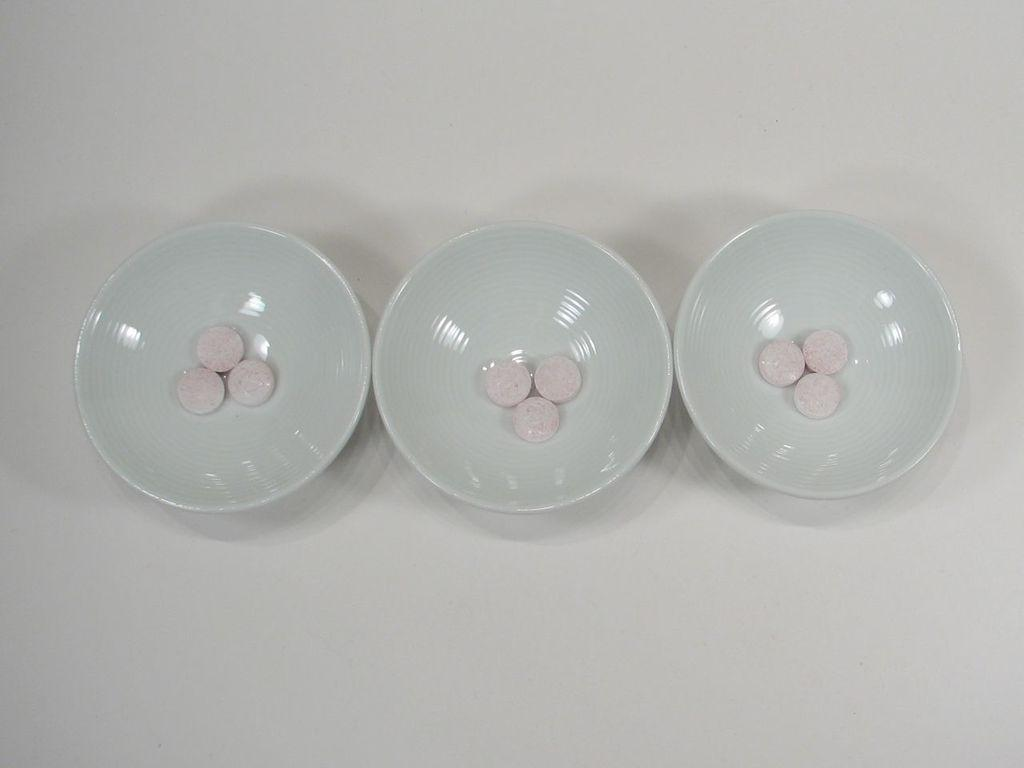How many bowls are visible in the image? There are three bowls in the image. What is inside the bowls? The bowls contain objects. What is the color of the object on which the bowls are placed? The bowls are placed on a white color object. Are there any rods visible in the image? There is no mention of rods in the provided facts, and therefore no such objects can be observed in the image. 